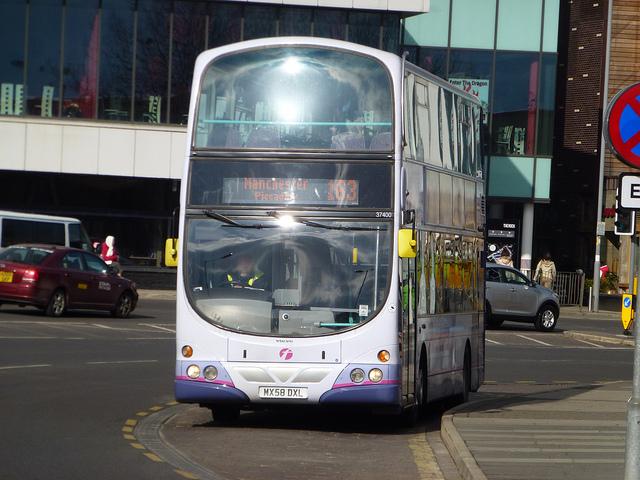What kind of bus is this?
Be succinct. Double decker. Where is the bus going?
Quick response, please. Manchester. How many levels does the bus have?
Concise answer only. 2. How many vehicles are in the picture?
Be succinct. 4. 